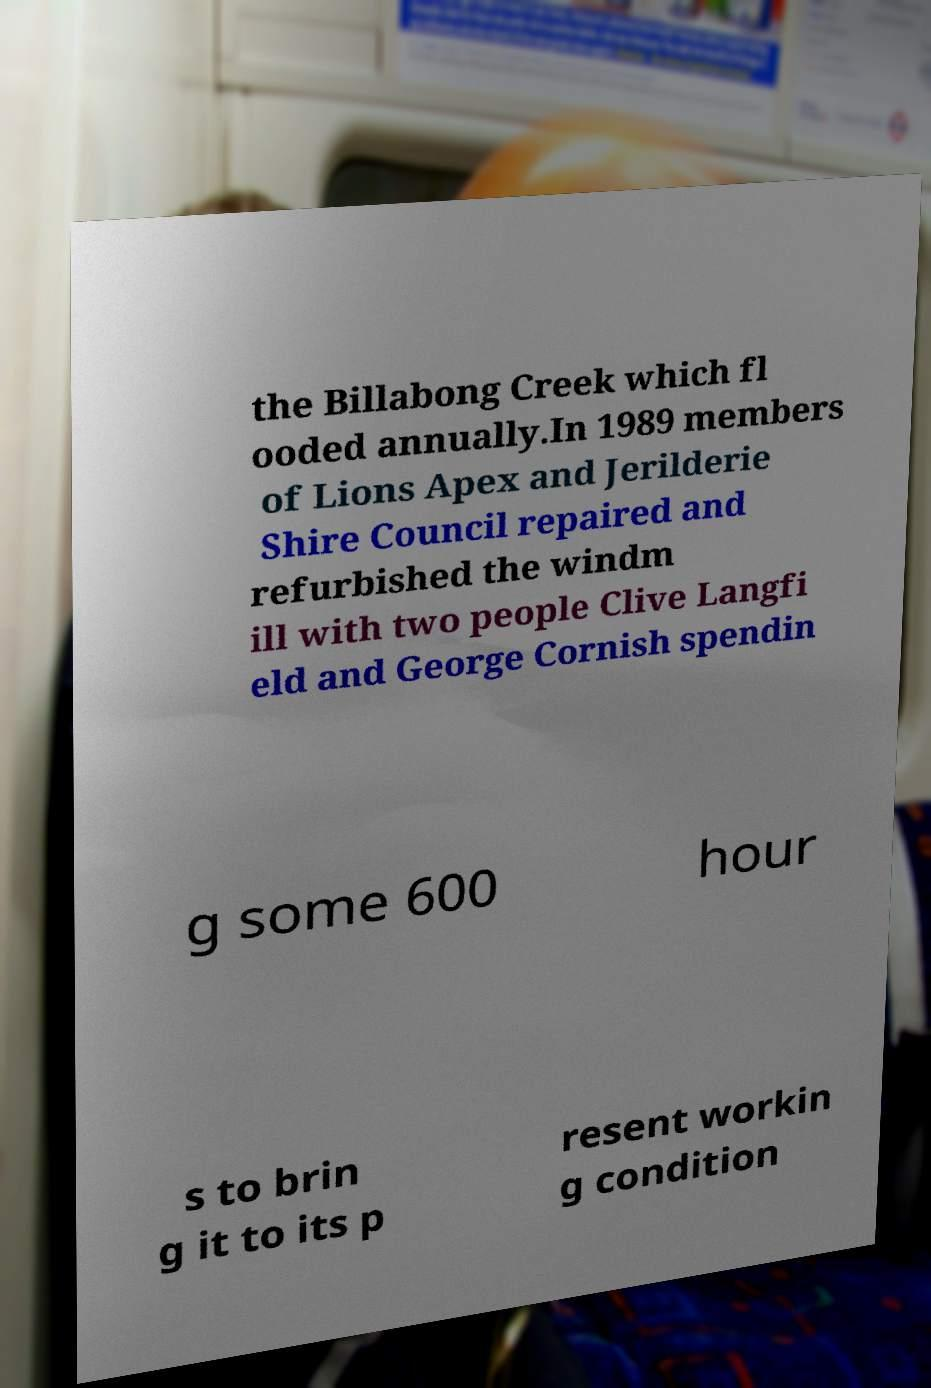Could you extract and type out the text from this image? the Billabong Creek which fl ooded annually.In 1989 members of Lions Apex and Jerilderie Shire Council repaired and refurbished the windm ill with two people Clive Langfi eld and George Cornish spendin g some 600 hour s to brin g it to its p resent workin g condition 